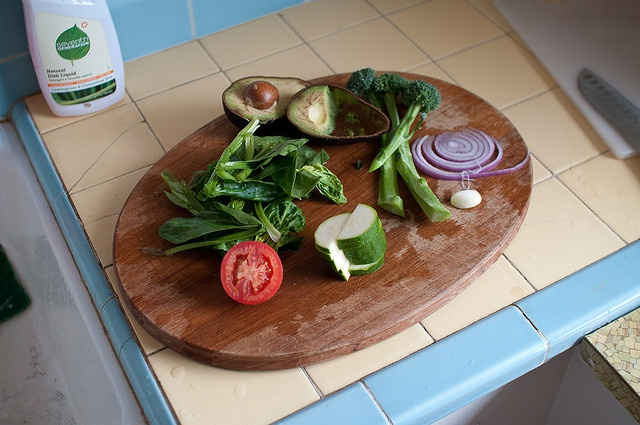Describe the objects in this image and their specific colors. I can see bottle in darkblue, lightgray, darkgray, and lightblue tones, knife in darkblue, gray, and black tones, broccoli in darkblue, black, darkgreen, teal, and green tones, broccoli in darkblue, black, and darkgreen tones, and broccoli in darkblue, black, teal, and darkgreen tones in this image. 